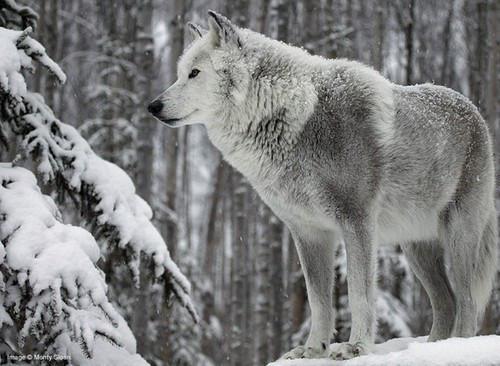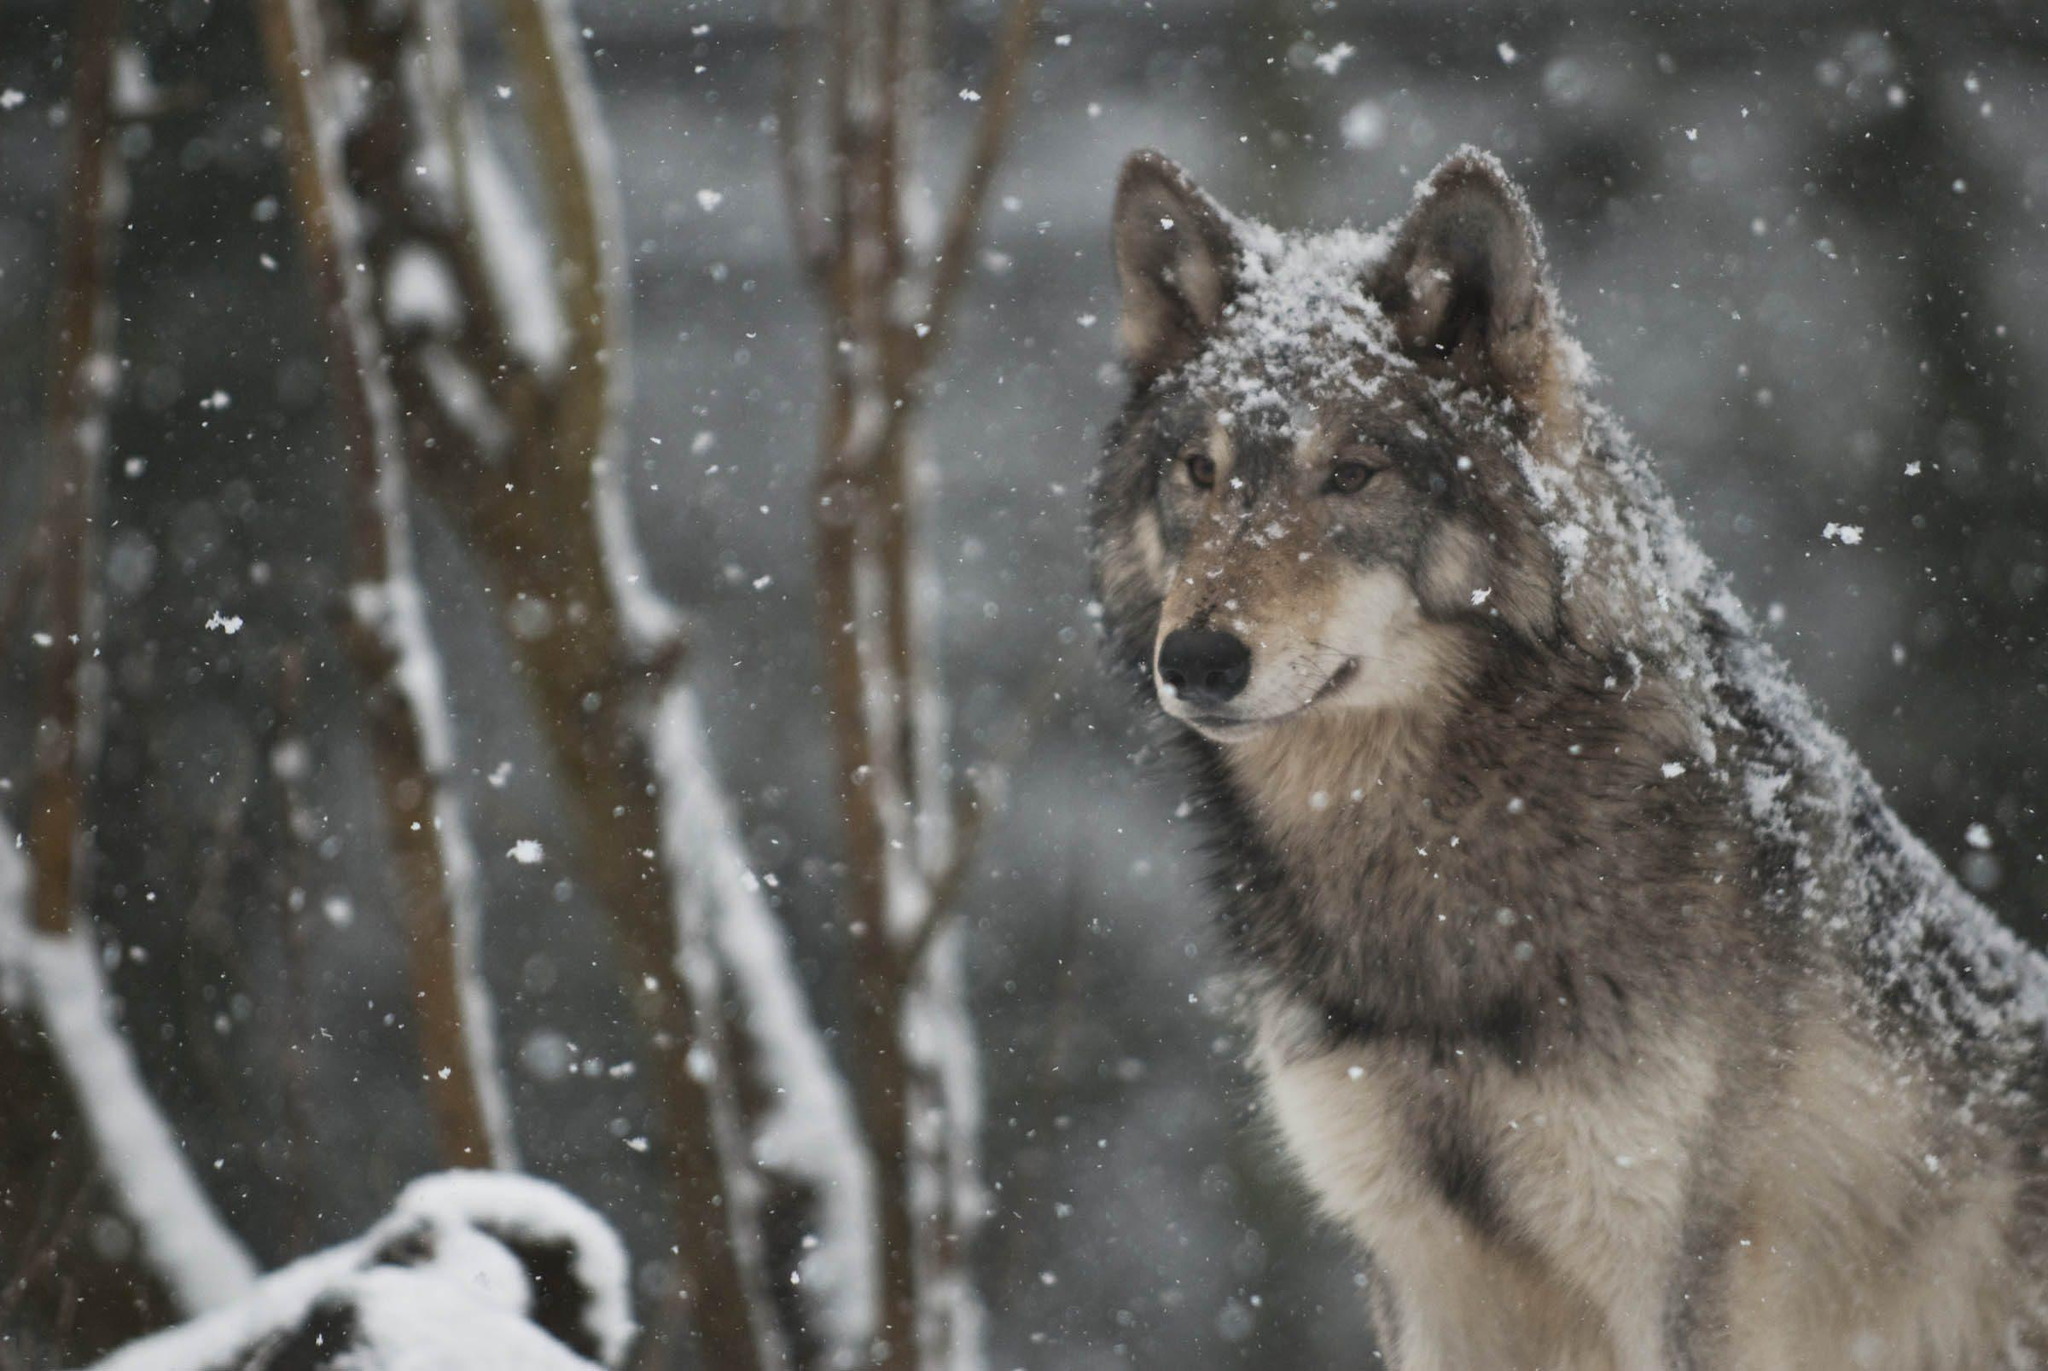The first image is the image on the left, the second image is the image on the right. Examine the images to the left and right. Is the description "At least one of the wolves is looking straight at the camera." accurate? Answer yes or no. No. The first image is the image on the left, the second image is the image on the right. Considering the images on both sides, is "The left image contains at least two wolves." valid? Answer yes or no. No. 